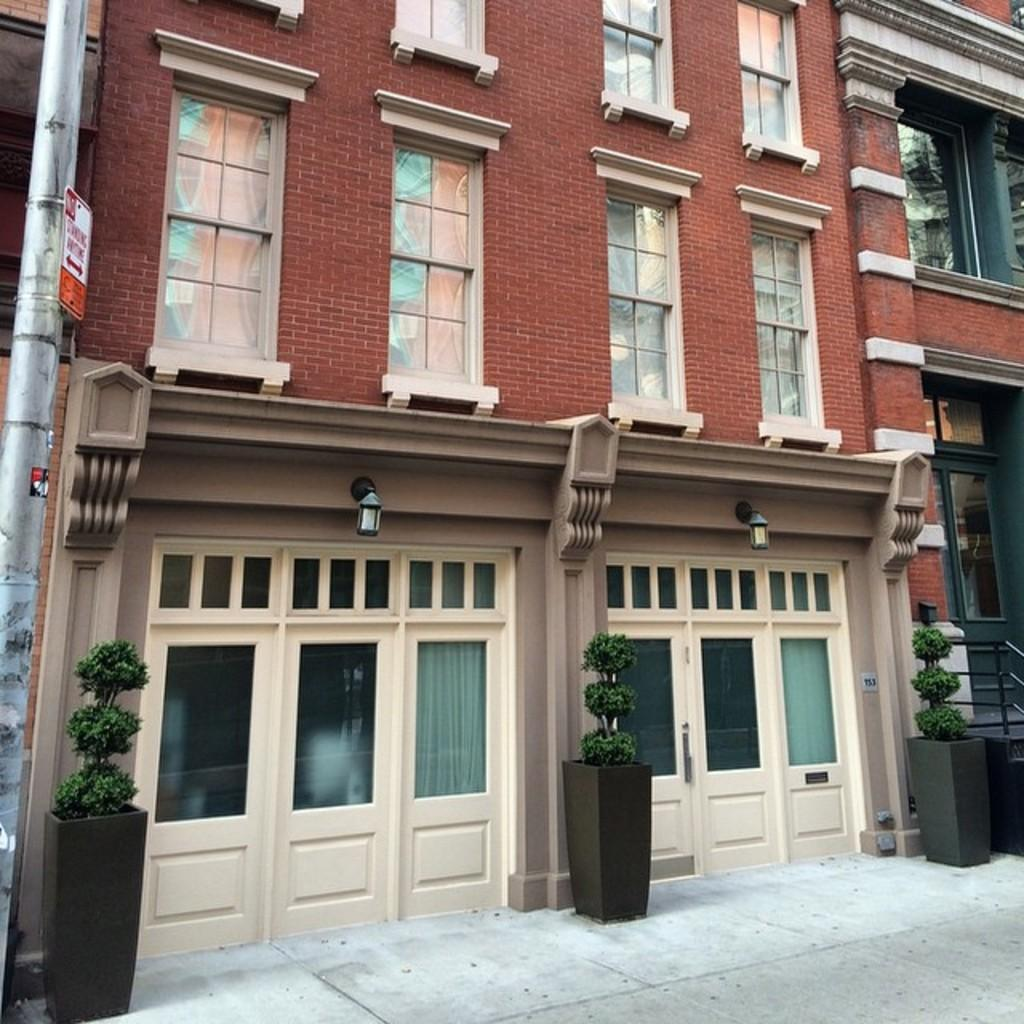What type of buildings are shown in the image? The buildings in the image have glass windows and doors. What can be seen in front of the buildings? Potted plants are present in front of the buildings. What is located on the left side of the image? There is a pole on the left side of the image. What type of cloud can be seen guiding the corn in the image? There are no clouds, guiding, or corn present in the image. 